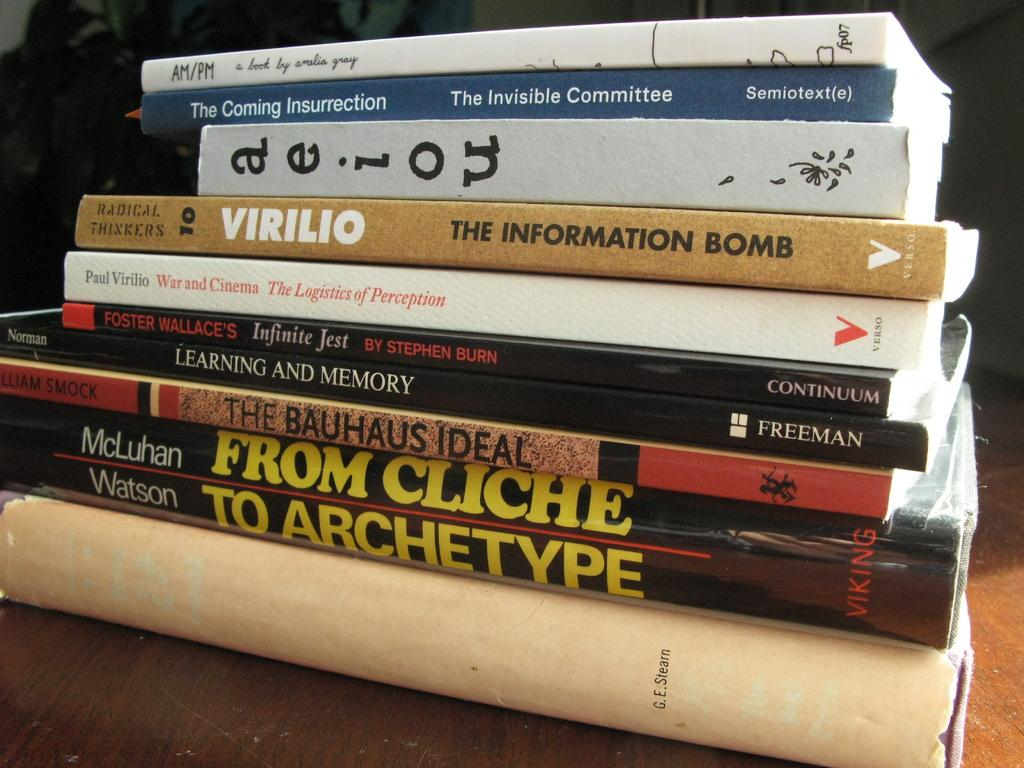Provide a one-sentence caption for the provided image. a variety of books stacked on top of each other including "from cliche to archetype". 